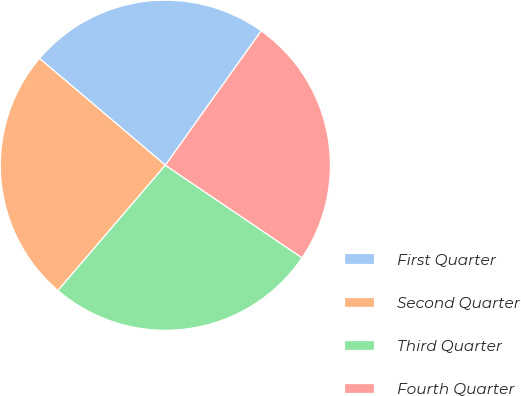Convert chart. <chart><loc_0><loc_0><loc_500><loc_500><pie_chart><fcel>First Quarter<fcel>Second Quarter<fcel>Third Quarter<fcel>Fourth Quarter<nl><fcel>23.67%<fcel>24.92%<fcel>26.81%<fcel>24.61%<nl></chart> 